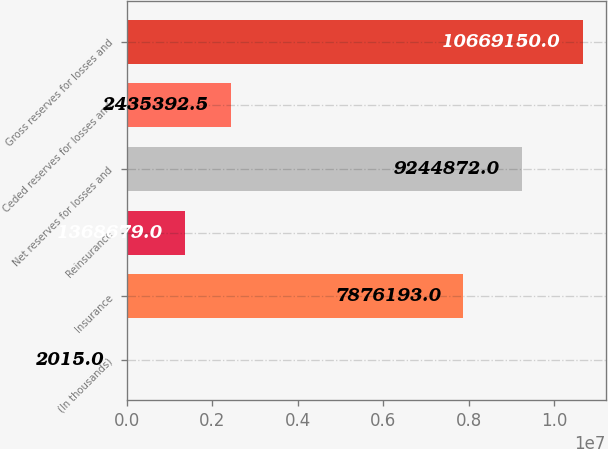<chart> <loc_0><loc_0><loc_500><loc_500><bar_chart><fcel>(In thousands)<fcel>Insurance<fcel>Reinsurance<fcel>Net reserves for losses and<fcel>Ceded reserves for losses and<fcel>Gross reserves for losses and<nl><fcel>2015<fcel>7.87619e+06<fcel>1.36868e+06<fcel>9.24487e+06<fcel>2.43539e+06<fcel>1.06692e+07<nl></chart> 